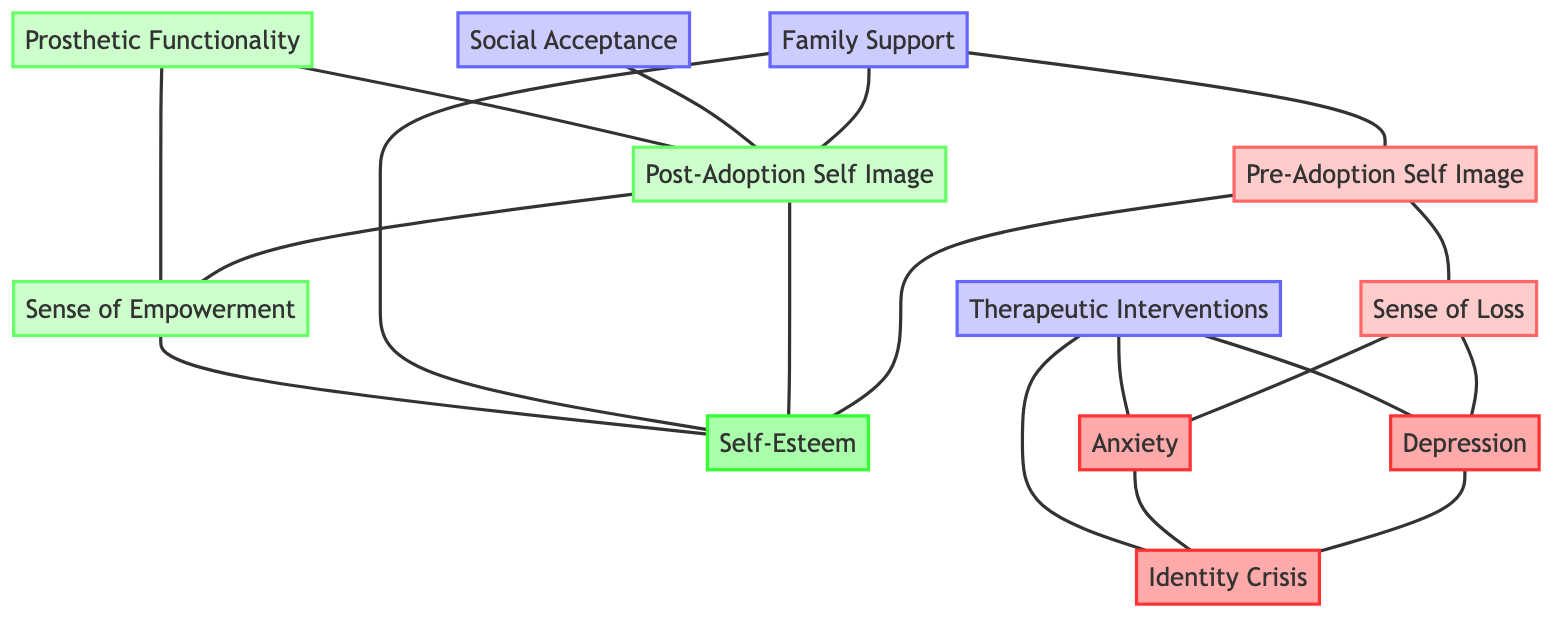What is the relationship between Pre-Adoption Self Image and Self-Esteem? The edge connects the node "Pre-Adoption Self Image" directly to "Self-Esteem," indicating a relationship.
Answer: Self-Esteem How many nodes are in the diagram? By counting all individual labeled elements, there are twelve nodes listed in the data, representing various emotional states and challenges.
Answer: Twelve What node is connected to both Family Support and Post-Adoption Self Image? The edge connects "Family Support" to both "Pre-Adoption Self Image" and "Post-Adoption Self Image," indicating it is directly related to both.
Answer: Self-Esteem What is the connection between Sense of Loss and Depression? There is a direct edge linking "Sense of Loss" to "Depression," indicating a relationship between the two emotional states.
Answer: Depression Which node shows a positive change from pre-adoption to post-adoption? Analyzing the connections, "Sense of Empowerment" is linked to "Post-Adoption Self Image," indicating a positive change.
Answer: Sense of Empowerment Which supportive node contributes to the increase of both Self-Esteem and Post-Adoption Self Image? The node "Family Support" connects to "Post-Adoption Self Image" and "Self-Esteem," showing its role in contributing to these states.
Answer: Family Support What is the direct effect of Therapeutic Interventions on Identity Crisis? The edge from "Therapeutic Interventions" to "Identity Crisis" indicates that therapeutic efforts have a direct impact on this emotional state.
Answer: Identity Crisis What is the primary emotional challenge linked to Sense of Loss? Counting the connections, it links to "Depression" and "Anxiety" directly, showing its primary emotional challenges.
Answer: Depression What is the relationship between Prosthetic Functionality and Sense of Empowerment? The edge from "Prosthetic Functionality" to "Sense of Empowerment" indicates that the effectiveness of the prosthetic relates directly to feelings of empowerment.
Answer: Sense of Empowerment 